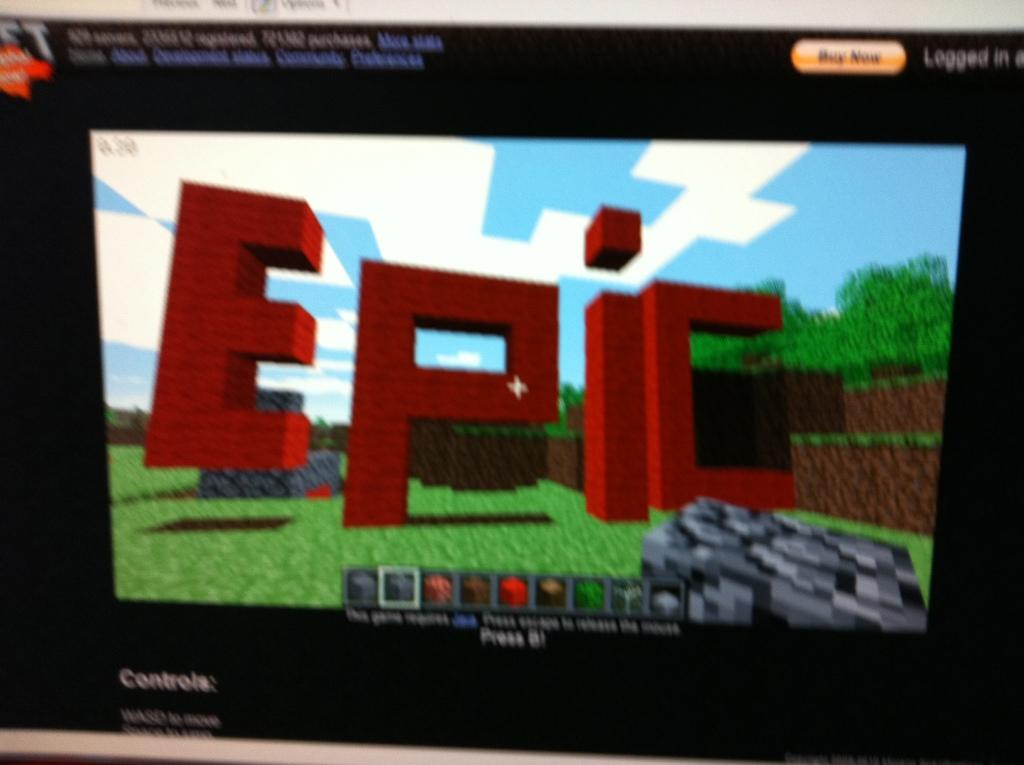<image>
Present a compact description of the photo's key features. A computer display of a video with the word epic in red. 